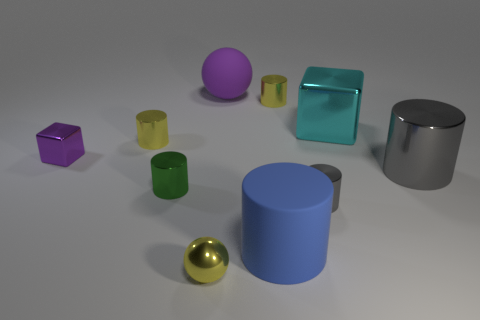Are there any other things that have the same shape as the purple rubber object?
Your response must be concise. Yes. Is the number of big blue cylinders on the right side of the large metal cylinder greater than the number of tiny shiny blocks in front of the rubber cylinder?
Keep it short and to the point. No. What number of yellow metallic cylinders are behind the yellow shiny cylinder that is to the left of the purple matte thing?
Your answer should be compact. 1. What number of things are either brown matte blocks or spheres?
Keep it short and to the point. 2. Is the green metal object the same shape as the large blue object?
Make the answer very short. Yes. What is the small gray object made of?
Your answer should be compact. Metal. What number of large things are in front of the big ball and behind the tiny green cylinder?
Your answer should be compact. 2. Do the rubber cylinder and the cyan thing have the same size?
Provide a short and direct response. Yes. There is a gray cylinder that is in front of the green cylinder; does it have the same size as the tiny purple shiny cube?
Give a very brief answer. Yes. There is a metallic block that is on the right side of the big sphere; what is its color?
Your answer should be very brief. Cyan. 